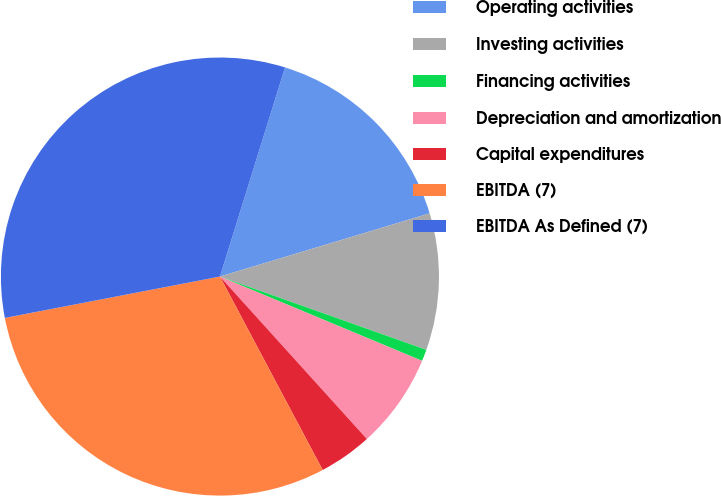Convert chart to OTSL. <chart><loc_0><loc_0><loc_500><loc_500><pie_chart><fcel>Operating activities<fcel>Investing activities<fcel>Financing activities<fcel>Depreciation and amortization<fcel>Capital expenditures<fcel>EBITDA (7)<fcel>EBITDA As Defined (7)<nl><fcel>15.54%<fcel>10.09%<fcel>0.86%<fcel>7.01%<fcel>3.93%<fcel>29.75%<fcel>32.83%<nl></chart> 